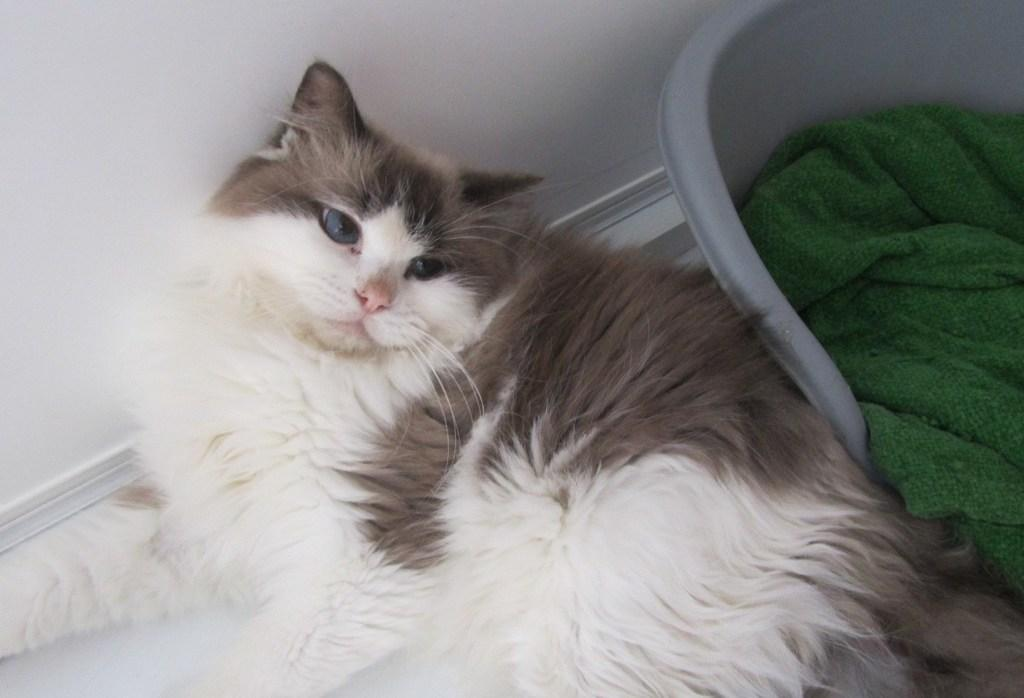What type of animal is in the image? There is a cat in the image. What is the cat doing in the image? The cat is lying on the floor. What can be seen in the background of the image? There is a wall and a towel in the background of the image. What type of gun is the cat holding in the image? There is no gun present in the image; the cat is simply lying on the floor. 